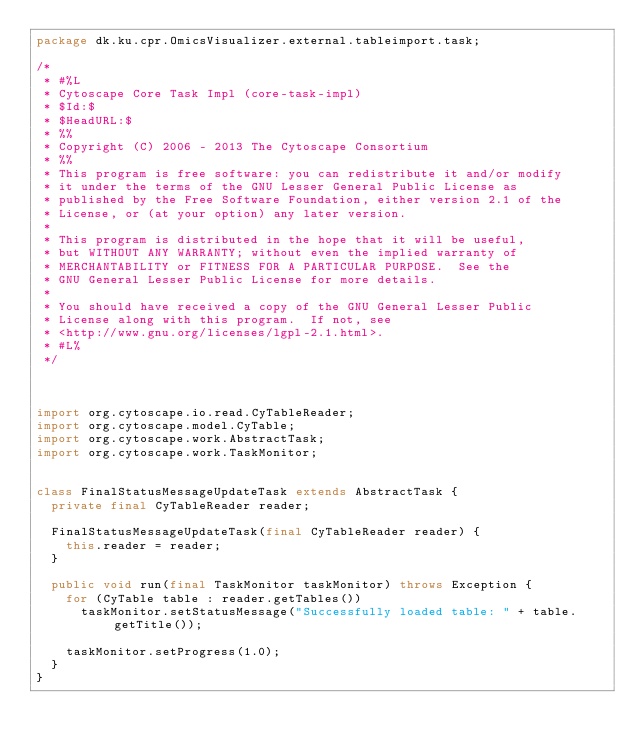<code> <loc_0><loc_0><loc_500><loc_500><_Java_>package dk.ku.cpr.OmicsVisualizer.external.tableimport.task;

/*
 * #%L
 * Cytoscape Core Task Impl (core-task-impl)
 * $Id:$
 * $HeadURL:$
 * %%
 * Copyright (C) 2006 - 2013 The Cytoscape Consortium
 * %%
 * This program is free software: you can redistribute it and/or modify
 * it under the terms of the GNU Lesser General Public License as 
 * published by the Free Software Foundation, either version 2.1 of the 
 * License, or (at your option) any later version.
 * 
 * This program is distributed in the hope that it will be useful,
 * but WITHOUT ANY WARRANTY; without even the implied warranty of
 * MERCHANTABILITY or FITNESS FOR A PARTICULAR PURPOSE.  See the
 * GNU General Lesser Public License for more details.
 * 
 * You should have received a copy of the GNU General Lesser Public 
 * License along with this program.  If not, see
 * <http://www.gnu.org/licenses/lgpl-2.1.html>.
 * #L%
 */



import org.cytoscape.io.read.CyTableReader;
import org.cytoscape.model.CyTable;
import org.cytoscape.work.AbstractTask;
import org.cytoscape.work.TaskMonitor;


class FinalStatusMessageUpdateTask extends AbstractTask {
	private final CyTableReader reader;
	
	FinalStatusMessageUpdateTask(final CyTableReader reader) {
		this.reader = reader;
	}

	public void run(final TaskMonitor taskMonitor) throws Exception {
		for (CyTable table : reader.getTables())
			taskMonitor.setStatusMessage("Successfully loaded table: " + table.getTitle());

		taskMonitor.setProgress(1.0);
	}
}
</code> 